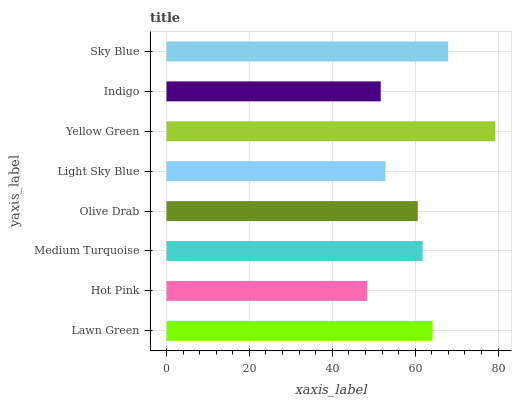Is Hot Pink the minimum?
Answer yes or no. Yes. Is Yellow Green the maximum?
Answer yes or no. Yes. Is Medium Turquoise the minimum?
Answer yes or no. No. Is Medium Turquoise the maximum?
Answer yes or no. No. Is Medium Turquoise greater than Hot Pink?
Answer yes or no. Yes. Is Hot Pink less than Medium Turquoise?
Answer yes or no. Yes. Is Hot Pink greater than Medium Turquoise?
Answer yes or no. No. Is Medium Turquoise less than Hot Pink?
Answer yes or no. No. Is Medium Turquoise the high median?
Answer yes or no. Yes. Is Olive Drab the low median?
Answer yes or no. Yes. Is Olive Drab the high median?
Answer yes or no. No. Is Lawn Green the low median?
Answer yes or no. No. 